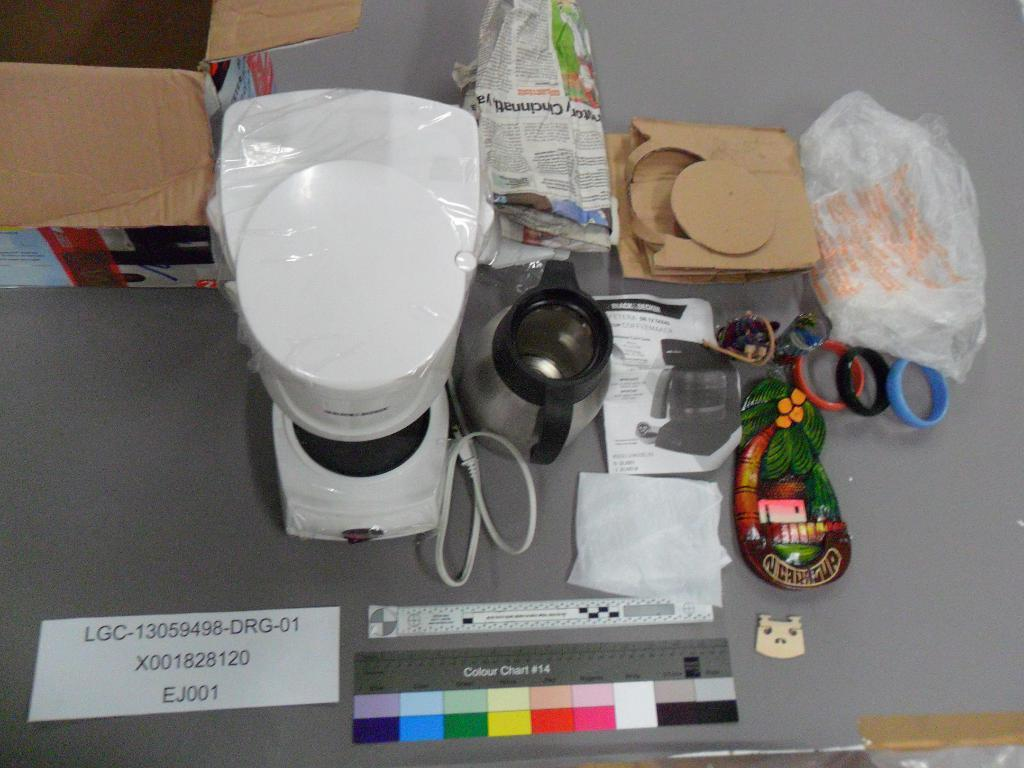Provide a one-sentence caption for the provided image. A gray table is littered with various random items, including coffee making materials and a visual aid called Colour Chart #14. 